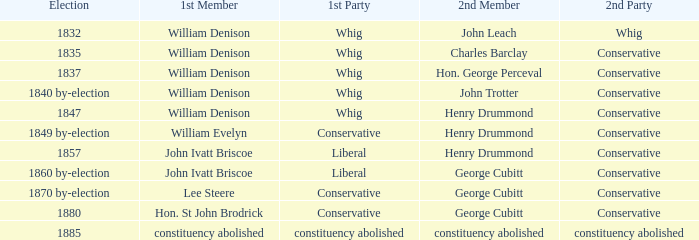Which party's 1st member is William Denison in the election of 1832? Whig. 